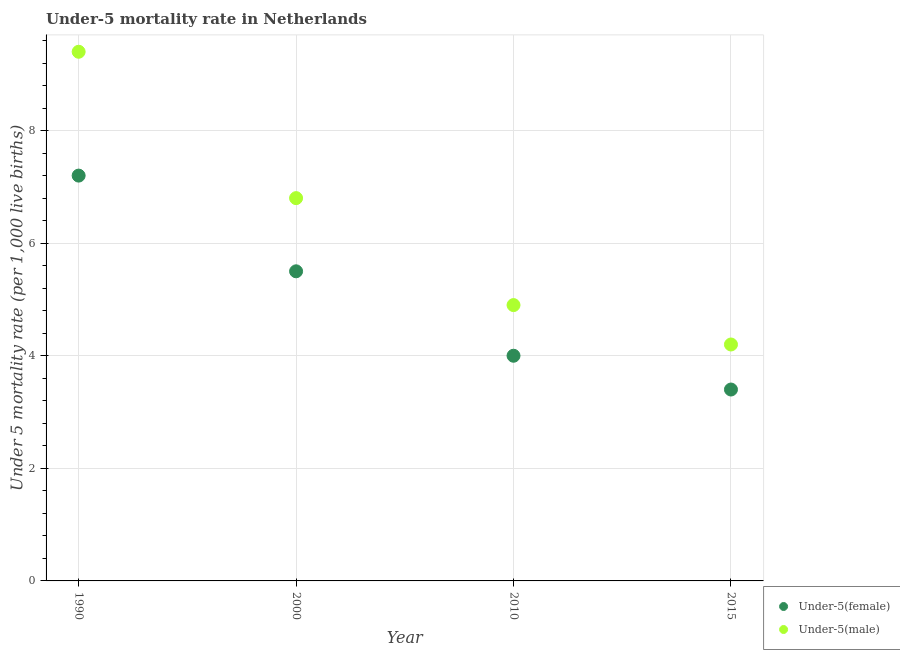What is the under-5 female mortality rate in 1990?
Keep it short and to the point. 7.2. Across all years, what is the maximum under-5 female mortality rate?
Make the answer very short. 7.2. Across all years, what is the minimum under-5 female mortality rate?
Provide a succinct answer. 3.4. In which year was the under-5 female mortality rate maximum?
Keep it short and to the point. 1990. In which year was the under-5 male mortality rate minimum?
Provide a succinct answer. 2015. What is the total under-5 male mortality rate in the graph?
Ensure brevity in your answer.  25.3. What is the difference between the under-5 female mortality rate in 2010 and that in 2015?
Provide a succinct answer. 0.6. What is the average under-5 male mortality rate per year?
Ensure brevity in your answer.  6.33. In the year 2010, what is the difference between the under-5 male mortality rate and under-5 female mortality rate?
Offer a terse response. 0.9. In how many years, is the under-5 male mortality rate greater than 4?
Your response must be concise. 4. What is the ratio of the under-5 female mortality rate in 2000 to that in 2015?
Provide a short and direct response. 1.62. Is the under-5 male mortality rate in 1990 less than that in 2015?
Provide a short and direct response. No. Is the difference between the under-5 male mortality rate in 1990 and 2015 greater than the difference between the under-5 female mortality rate in 1990 and 2015?
Provide a succinct answer. Yes. What is the difference between the highest and the second highest under-5 male mortality rate?
Provide a short and direct response. 2.6. Is the sum of the under-5 female mortality rate in 2010 and 2015 greater than the maximum under-5 male mortality rate across all years?
Keep it short and to the point. No. How many years are there in the graph?
Your answer should be very brief. 4. What is the difference between two consecutive major ticks on the Y-axis?
Give a very brief answer. 2. Are the values on the major ticks of Y-axis written in scientific E-notation?
Provide a short and direct response. No. What is the title of the graph?
Keep it short and to the point. Under-5 mortality rate in Netherlands. What is the label or title of the X-axis?
Your answer should be compact. Year. What is the label or title of the Y-axis?
Your answer should be very brief. Under 5 mortality rate (per 1,0 live births). What is the Under 5 mortality rate (per 1,000 live births) of Under-5(female) in 1990?
Give a very brief answer. 7.2. What is the Under 5 mortality rate (per 1,000 live births) of Under-5(male) in 1990?
Offer a terse response. 9.4. What is the Under 5 mortality rate (per 1,000 live births) of Under-5(female) in 2000?
Make the answer very short. 5.5. What is the Under 5 mortality rate (per 1,000 live births) in Under-5(male) in 2010?
Offer a very short reply. 4.9. What is the Under 5 mortality rate (per 1,000 live births) in Under-5(female) in 2015?
Keep it short and to the point. 3.4. Across all years, what is the maximum Under 5 mortality rate (per 1,000 live births) in Under-5(female)?
Provide a short and direct response. 7.2. Across all years, what is the maximum Under 5 mortality rate (per 1,000 live births) of Under-5(male)?
Provide a succinct answer. 9.4. Across all years, what is the minimum Under 5 mortality rate (per 1,000 live births) in Under-5(male)?
Keep it short and to the point. 4.2. What is the total Under 5 mortality rate (per 1,000 live births) of Under-5(female) in the graph?
Your answer should be very brief. 20.1. What is the total Under 5 mortality rate (per 1,000 live births) of Under-5(male) in the graph?
Provide a succinct answer. 25.3. What is the difference between the Under 5 mortality rate (per 1,000 live births) of Under-5(female) in 1990 and that in 2000?
Make the answer very short. 1.7. What is the difference between the Under 5 mortality rate (per 1,000 live births) of Under-5(female) in 1990 and that in 2015?
Your answer should be very brief. 3.8. What is the difference between the Under 5 mortality rate (per 1,000 live births) of Under-5(female) in 2000 and that in 2015?
Keep it short and to the point. 2.1. What is the difference between the Under 5 mortality rate (per 1,000 live births) in Under-5(female) in 2010 and that in 2015?
Keep it short and to the point. 0.6. What is the difference between the Under 5 mortality rate (per 1,000 live births) of Under-5(female) in 1990 and the Under 5 mortality rate (per 1,000 live births) of Under-5(male) in 2000?
Provide a succinct answer. 0.4. What is the difference between the Under 5 mortality rate (per 1,000 live births) in Under-5(female) in 1990 and the Under 5 mortality rate (per 1,000 live births) in Under-5(male) in 2010?
Offer a very short reply. 2.3. What is the difference between the Under 5 mortality rate (per 1,000 live births) of Under-5(female) in 1990 and the Under 5 mortality rate (per 1,000 live births) of Under-5(male) in 2015?
Ensure brevity in your answer.  3. What is the difference between the Under 5 mortality rate (per 1,000 live births) in Under-5(female) in 2000 and the Under 5 mortality rate (per 1,000 live births) in Under-5(male) in 2015?
Your answer should be compact. 1.3. What is the difference between the Under 5 mortality rate (per 1,000 live births) of Under-5(female) in 2010 and the Under 5 mortality rate (per 1,000 live births) of Under-5(male) in 2015?
Provide a short and direct response. -0.2. What is the average Under 5 mortality rate (per 1,000 live births) of Under-5(female) per year?
Ensure brevity in your answer.  5.03. What is the average Under 5 mortality rate (per 1,000 live births) in Under-5(male) per year?
Provide a short and direct response. 6.33. In the year 2000, what is the difference between the Under 5 mortality rate (per 1,000 live births) of Under-5(female) and Under 5 mortality rate (per 1,000 live births) of Under-5(male)?
Your answer should be very brief. -1.3. In the year 2010, what is the difference between the Under 5 mortality rate (per 1,000 live births) of Under-5(female) and Under 5 mortality rate (per 1,000 live births) of Under-5(male)?
Offer a terse response. -0.9. What is the ratio of the Under 5 mortality rate (per 1,000 live births) of Under-5(female) in 1990 to that in 2000?
Provide a short and direct response. 1.31. What is the ratio of the Under 5 mortality rate (per 1,000 live births) in Under-5(male) in 1990 to that in 2000?
Make the answer very short. 1.38. What is the ratio of the Under 5 mortality rate (per 1,000 live births) of Under-5(female) in 1990 to that in 2010?
Your answer should be compact. 1.8. What is the ratio of the Under 5 mortality rate (per 1,000 live births) in Under-5(male) in 1990 to that in 2010?
Provide a succinct answer. 1.92. What is the ratio of the Under 5 mortality rate (per 1,000 live births) in Under-5(female) in 1990 to that in 2015?
Provide a succinct answer. 2.12. What is the ratio of the Under 5 mortality rate (per 1,000 live births) in Under-5(male) in 1990 to that in 2015?
Your answer should be compact. 2.24. What is the ratio of the Under 5 mortality rate (per 1,000 live births) of Under-5(female) in 2000 to that in 2010?
Offer a very short reply. 1.38. What is the ratio of the Under 5 mortality rate (per 1,000 live births) of Under-5(male) in 2000 to that in 2010?
Offer a terse response. 1.39. What is the ratio of the Under 5 mortality rate (per 1,000 live births) of Under-5(female) in 2000 to that in 2015?
Make the answer very short. 1.62. What is the ratio of the Under 5 mortality rate (per 1,000 live births) in Under-5(male) in 2000 to that in 2015?
Ensure brevity in your answer.  1.62. What is the ratio of the Under 5 mortality rate (per 1,000 live births) in Under-5(female) in 2010 to that in 2015?
Your response must be concise. 1.18. What is the difference between the highest and the lowest Under 5 mortality rate (per 1,000 live births) in Under-5(female)?
Keep it short and to the point. 3.8. 